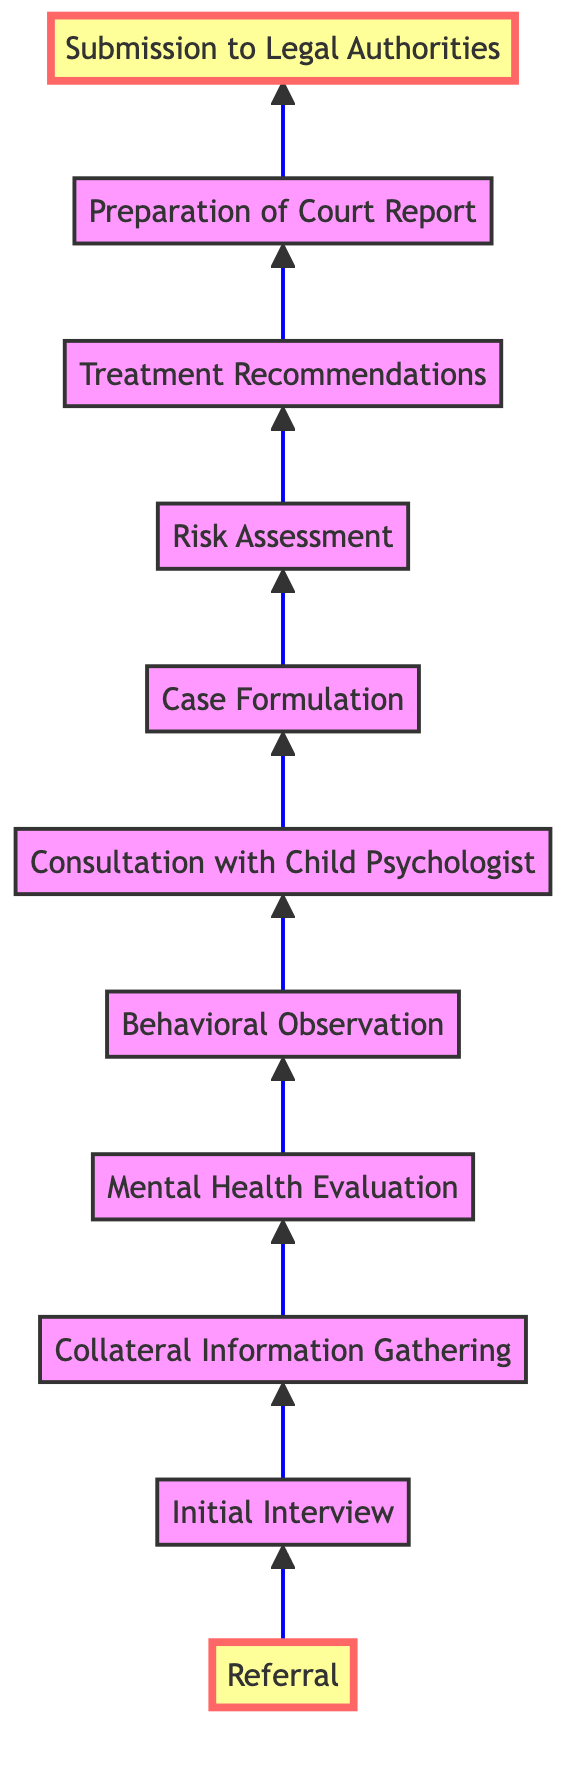What is the first step in the assessment process? The first step indicated in the diagram is "Referral," as it appears at the bottom and leads to the next step.
Answer: Referral How many steps are there in total in the assessment process? By counting all the nodes in the diagram from "Referral" to "Submission to Legal Authorities," there are eleven distinct steps.
Answer: Eleven What is the last step before the court report is prepared? The step just before "Preparation of Court Report" is "Treatment Recommendations," which directly leads into the report preparation phase.
Answer: Treatment Recommendations Which step follows "Risk Assessment"? The step that follows "Risk Assessment" is "Treatment Recommendations," as indicated by the directional arrow from the risk assessment phase to the recommendations.
Answer: Treatment Recommendations How many steps are there from "Initial Interview" to "Consultation with Child Psychologist"? There are four steps in total from "Initial Interview" to "Consultation with Child Psychologist," which are "Initial Interview," "Collateral Information Gathering," "Mental Health Evaluation," and "Behavioral Observation."
Answer: Four What is the relationship between "Preparation of Court Report" and "Submission to Legal Authorities"? "Preparation of Court Report" is directly followed by "Submission to Legal Authorities," indicating that the preparation leads directly into submission.
Answer: Direct relationship What is the primary purpose of the "Collateral Information Gathering" step? The purpose of "Collateral Information Gathering" is to collect medical, educational, social, and legal records, which are crucial for further evaluation.
Answer: Collection of records Which step primarily focuses on the child's behavior? The step that focuses on observing the child's behavior is "Behavioral Observation," which is specifically aimed at direct observation in various settings.
Answer: Behavioral Observation Is "Consultation with Child Psychologist" primarily a solitary or collaborative process? The step indicates that it is a collaborative process, as it involves a case discussion and involves exchanging findings and insights with the child psychologist.
Answer: Collaborative process 